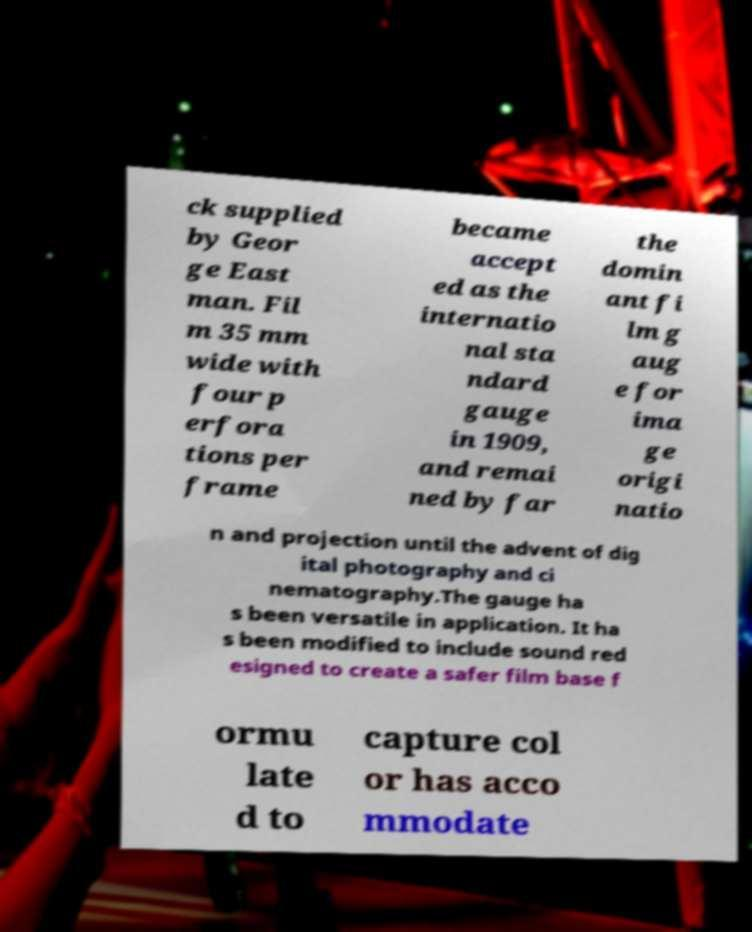Could you assist in decoding the text presented in this image and type it out clearly? ck supplied by Geor ge East man. Fil m 35 mm wide with four p erfora tions per frame became accept ed as the internatio nal sta ndard gauge in 1909, and remai ned by far the domin ant fi lm g aug e for ima ge origi natio n and projection until the advent of dig ital photography and ci nematography.The gauge ha s been versatile in application. It ha s been modified to include sound red esigned to create a safer film base f ormu late d to capture col or has acco mmodate 